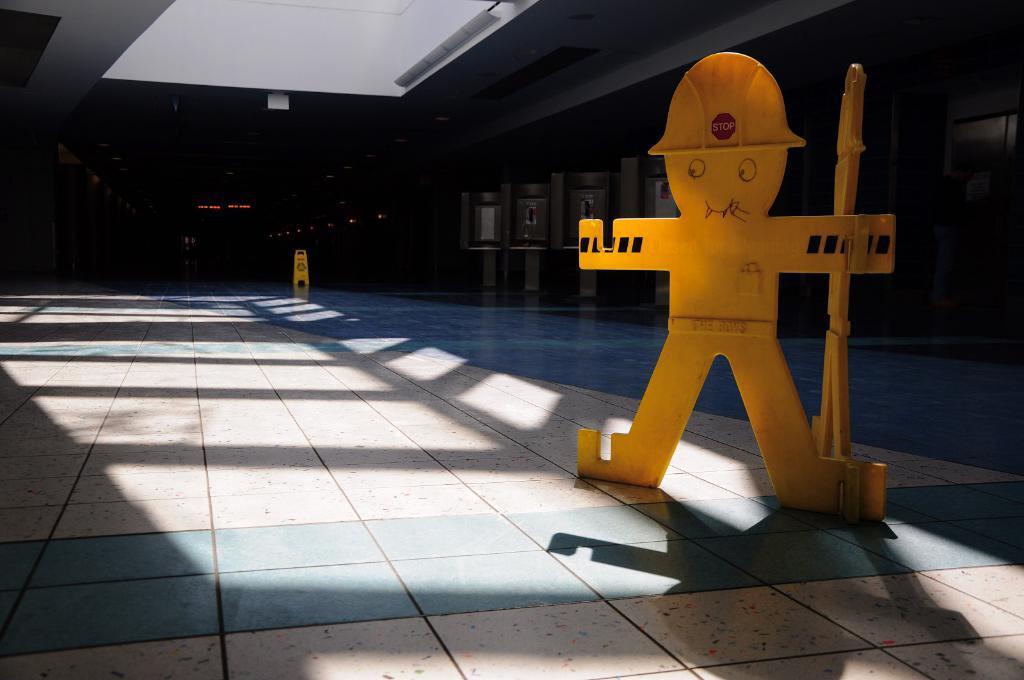How would you summarize this image in a sentence or two? There is a depiction of a person in the image. There is tile flooring at the bottom of the image. 